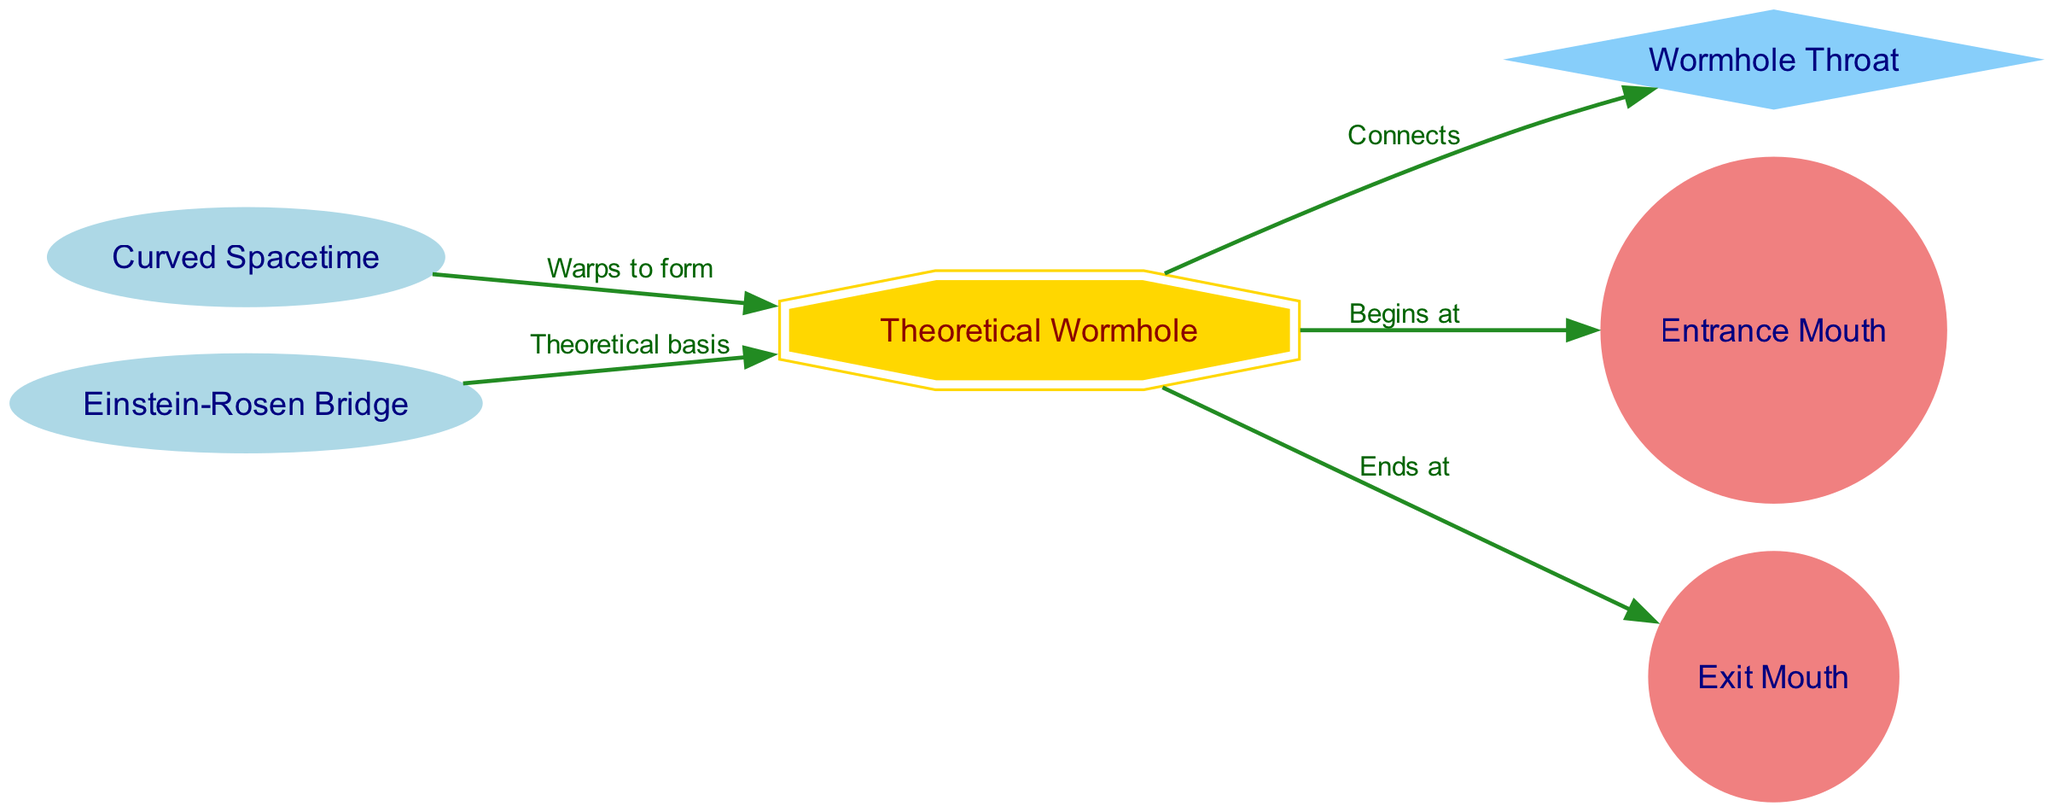What is the label of the node representing the wormhole's opening? The diagram shows two entrance points for the wormhole, labeled as "Entrance Mouth" and "Exit Mouth." Since the question specifically asks for the opening, the relevant node is "Entrance Mouth."
Answer: Entrance Mouth How many nodes are shown in the diagram? The diagram includes six nodes: Theoretical Wormhole, Wormhole Throat, Entrance Mouth, Exit Mouth, Curved Spacetime, and Einstein-Rosen Bridge. Therefore, counting these gives a total of six nodes.
Answer: 6 What connects to the Wormhole Throat? The diagram indicates a connection between the "Theoretical Wormhole" and the "Wormhole Throat," explicitly labeled as "Connects." This highlights the relationship where the throat is a specific section of the wormhole structure.
Answer: Wormhole What does Spacetime warp to form? The relationship depicted in the diagram shows that "Curved Spacetime" warps to form the "Theoretical Wormhole." This indicates that the structure of the wormhole is a result of the warping of spacetime in theory.
Answer: Theoretical Wormhole What is the theoretical basis of the wormhole? The diagram indicates that the "Einstein-Rosen Bridge" serves as the theoretical basis for the "Theoretical Wormhole." This highlights the foundational concept that connects these two elements in the diagram.
Answer: Einstein-Rosen Bridge What type of shape is used for the node that represents the throat? The diagram specifies that the node for "Wormhole Throat" is shaped as a diamond, which is a distinct format in contrast to other nodes. This use of shape helps to symbolize its unique role in the wormhole structure.
Answer: Diamond How many edges point from the wormhole? The diagram illustrates three edges emanating from the "Theoretical Wormhole": to "Wormhole Throat," "Entrance Mouth," and "Exit Mouth." This indicates the various connections and relationships associated with the wormhole structure.
Answer: 3 What labels the connection from the spacetime to the wormhole? The label for the edge connecting "Curved Spacetime" to "Theoretical Wormhole" is "Warps to form." This indicates specifically how spacetime influences the formation of the wormhole.
Answer: Warps to form Which mouth does the wormhole end at? The diagram clearly labels the exit point of the wormhole as "Exit Mouth," denoting the direction through which travel occurs out of the wormhole.
Answer: Exit Mouth 